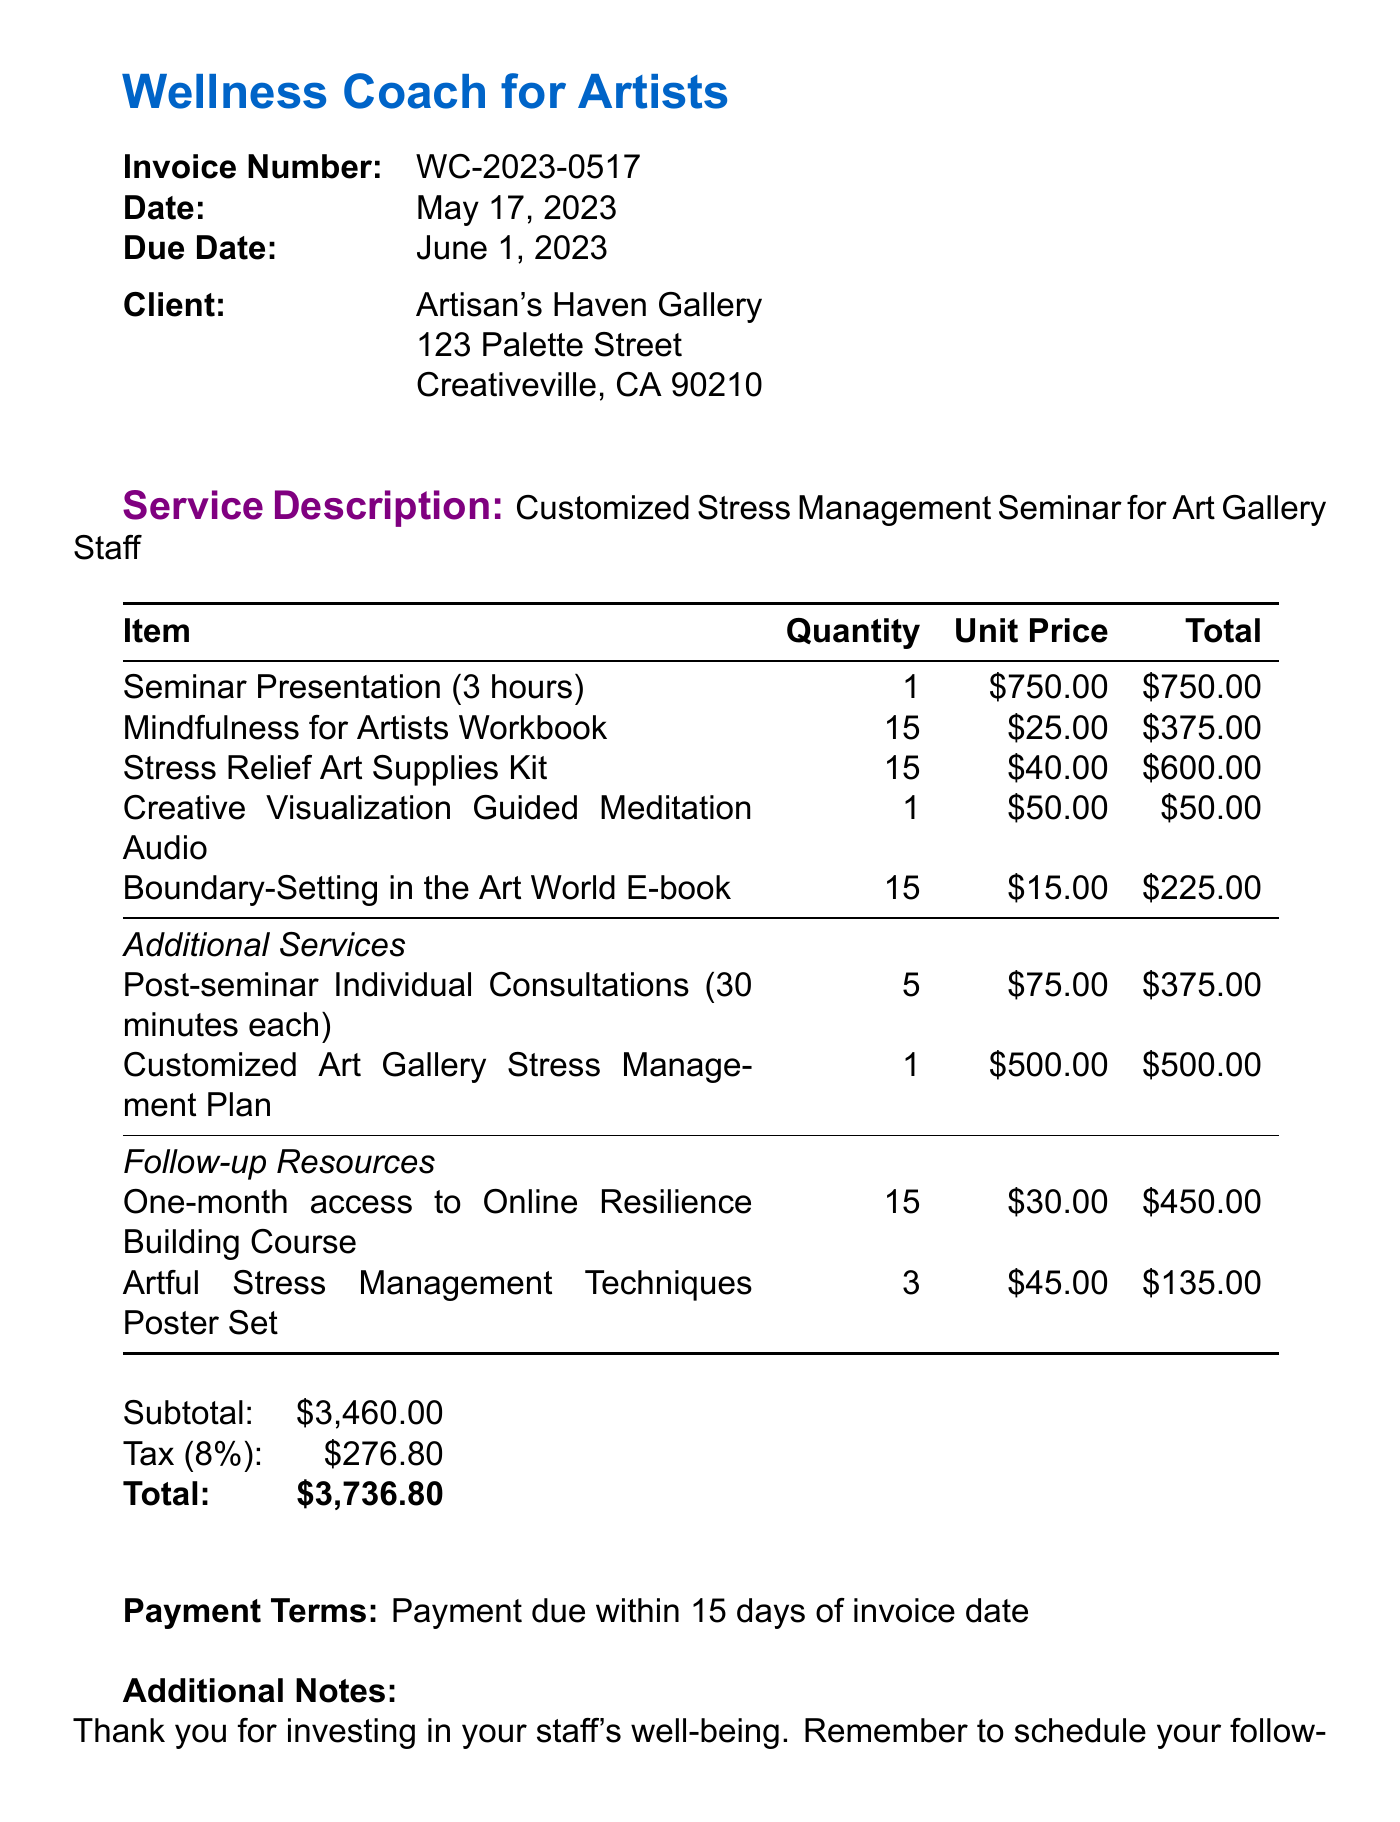What is the invoice number? The invoice number is specifically listed in the document under invoice details.
Answer: WC-2023-0517 Who is the client? The client name appears prominently in the invoice details section.
Answer: Artisan's Haven Gallery What is the total amount due? The total amount due is stated at the end of the invoice.
Answer: $3,736.80 How many mindfulness workbooks were included? The quantity of mindfulness workbooks is mentioned in the line items.
Answer: 15 What is the unit price of the seminar presentation? The unit price of the seminar presentation can be found next to the item description in the line items.
Answer: $750.00 What additional service includes individual consultations? The additional service that mentions individual consultations is specified in the additional services section.
Answer: Post-seminar Individual Consultations How many additional resources are listed? The number of follow-up resources can be counted in the follow-up resources section.
Answer: 2 What is the tax rate on the invoice? The tax rate is explicitly stated in the document under the financial summary.
Answer: 8% What is the payment term? The payment terms are clearly outlined towards the end of the invoice.
Answer: Payment due within 15 days of invoice date 